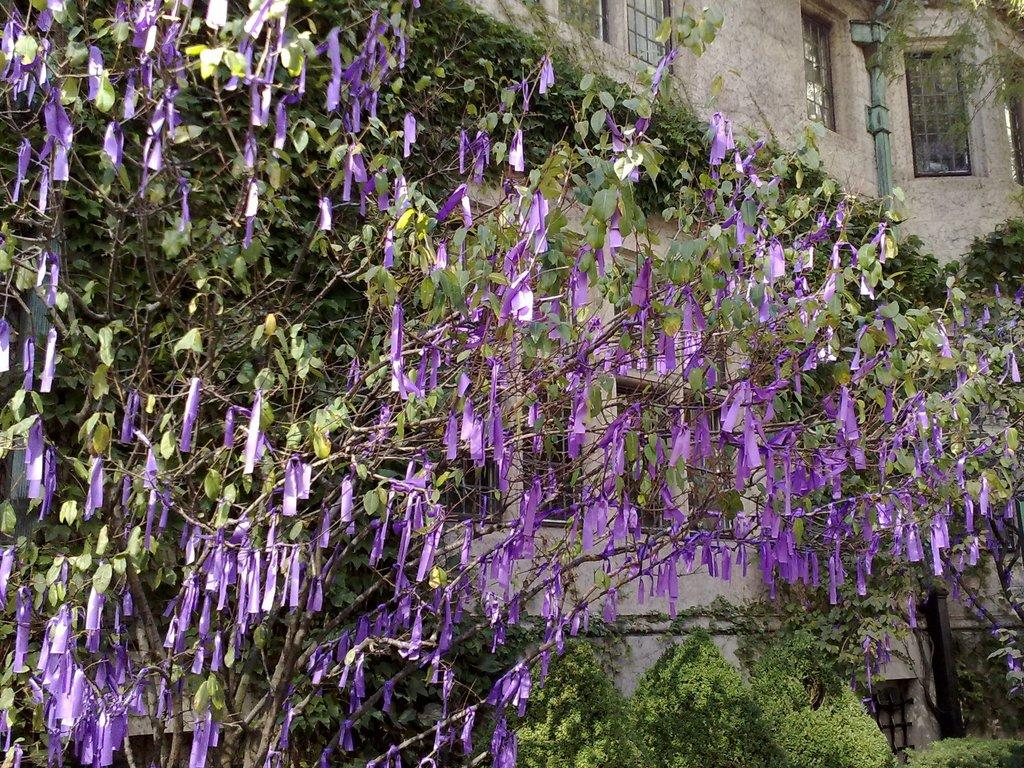What type of vegetation is visible in the foreground of the image? There are green leaves and a purple flower in the foreground of the image. Can you describe the color of the flower? The flower is purple. What type of structure can be seen in the background of the image? There is a house in the background of the image. What type of bread is being used to wash the soap in the image? There is no bread or soap present in the image; it features green leaves, a purple flower, and a house in the background. 